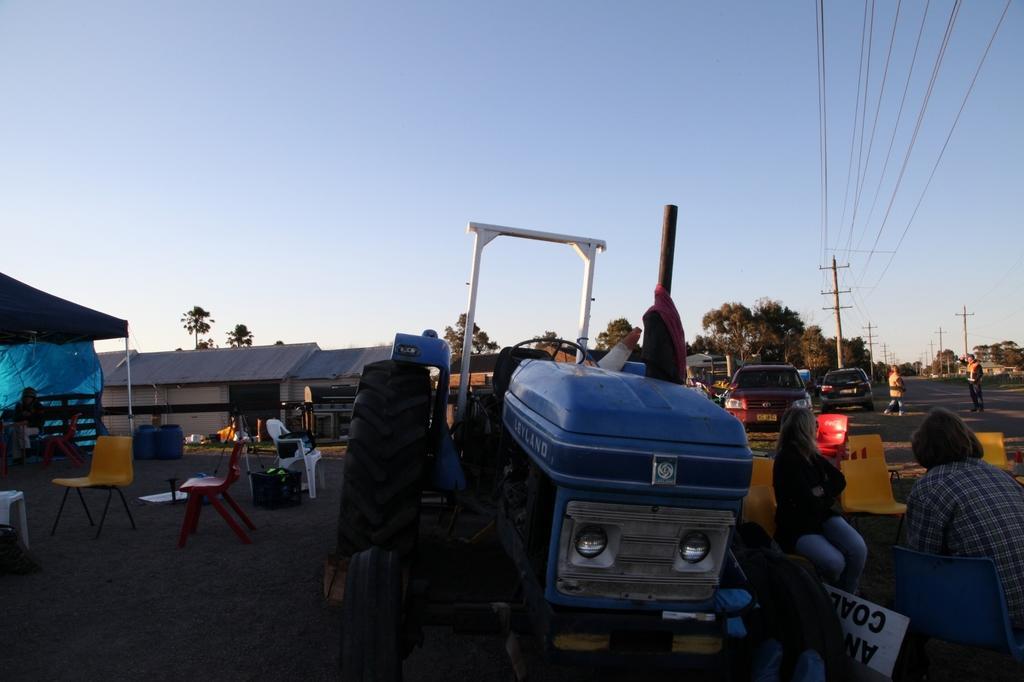In one or two sentences, can you explain what this image depicts? This picture is clicked outside the city. On the right bottom of the picture, we see two people sitting on chair. Beside them, we see a blue tractor and behind them, we see two cars and beside the cars, we see two people walking on road and we even see electric poles. Behind the poles, we see trees. On the left corner of the picture, we see blue tent under which we have a bench and behind that, we see a house with blue roof. 